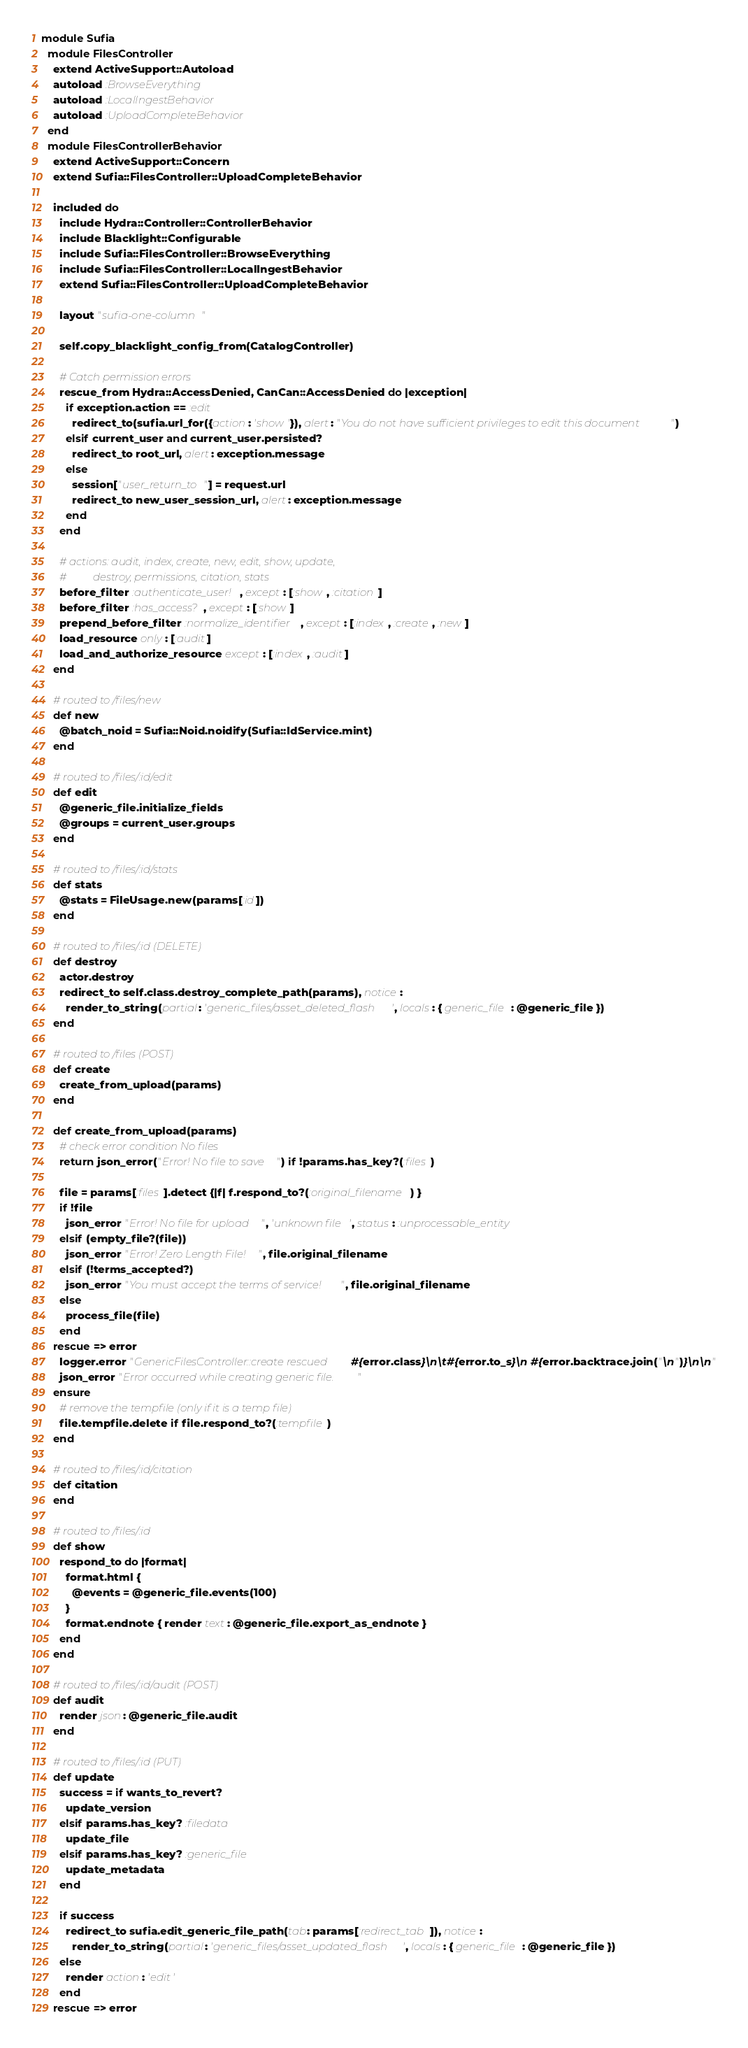Convert code to text. <code><loc_0><loc_0><loc_500><loc_500><_Ruby_>module Sufia
  module FilesController
    extend ActiveSupport::Autoload
    autoload :BrowseEverything
    autoload :LocalIngestBehavior
    autoload :UploadCompleteBehavior
  end
  module FilesControllerBehavior
    extend ActiveSupport::Concern
    extend Sufia::FilesController::UploadCompleteBehavior

    included do
      include Hydra::Controller::ControllerBehavior
      include Blacklight::Configurable
      include Sufia::FilesController::BrowseEverything
      include Sufia::FilesController::LocalIngestBehavior
      extend Sufia::FilesController::UploadCompleteBehavior

      layout "sufia-one-column"

      self.copy_blacklight_config_from(CatalogController)

      # Catch permission errors
      rescue_from Hydra::AccessDenied, CanCan::AccessDenied do |exception|
        if exception.action == :edit
          redirect_to(sufia.url_for({action: 'show'}), alert: "You do not have sufficient privileges to edit this document")
        elsif current_user and current_user.persisted?
          redirect_to root_url, alert: exception.message
        else
          session["user_return_to"] = request.url
          redirect_to new_user_session_url, alert: exception.message
        end
      end

      # actions: audit, index, create, new, edit, show, update,
      #          destroy, permissions, citation, stats
      before_filter :authenticate_user!, except: [:show, :citation]
      before_filter :has_access?, except: [:show]
      prepend_before_filter :normalize_identifier, except: [:index, :create, :new]
      load_resource only: [:audit]
      load_and_authorize_resource except: [:index, :audit]
    end

    # routed to /files/new
    def new
      @batch_noid = Sufia::Noid.noidify(Sufia::IdService.mint)
    end

    # routed to /files/:id/edit
    def edit
      @generic_file.initialize_fields
      @groups = current_user.groups
    end

    # routed to /files/:id/stats
    def stats
      @stats = FileUsage.new(params[:id])
    end

    # routed to /files/:id (DELETE)
    def destroy
      actor.destroy
      redirect_to self.class.destroy_complete_path(params), notice:
        render_to_string(partial: 'generic_files/asset_deleted_flash', locals: { generic_file: @generic_file })
    end

    # routed to /files (POST)
    def create
      create_from_upload(params)
    end

    def create_from_upload(params)
      # check error condition No files
      return json_error("Error! No file to save") if !params.has_key?(:files)

      file = params[:files].detect {|f| f.respond_to?(:original_filename) }
      if !file
        json_error "Error! No file for upload", 'unknown file', status: :unprocessable_entity
      elsif (empty_file?(file))
        json_error "Error! Zero Length File!", file.original_filename
      elsif (!terms_accepted?)
        json_error "You must accept the terms of service!", file.original_filename
      else
        process_file(file)
      end
    rescue => error
      logger.error "GenericFilesController::create rescued #{error.class}\n\t#{error.to_s}\n #{error.backtrace.join("\n")}\n\n"
      json_error "Error occurred while creating generic file."
    ensure
      # remove the tempfile (only if it is a temp file)
      file.tempfile.delete if file.respond_to?(:tempfile)
    end

    # routed to /files/:id/citation
    def citation
    end

    # routed to /files/:id
    def show
      respond_to do |format|
        format.html {
          @events = @generic_file.events(100)
        }
        format.endnote { render text: @generic_file.export_as_endnote }
      end
    end

    # routed to /files/:id/audit (POST)
    def audit
      render json: @generic_file.audit
    end

    # routed to /files/:id (PUT)
    def update
      success = if wants_to_revert?
        update_version
      elsif params.has_key? :filedata
        update_file
      elsif params.has_key? :generic_file
        update_metadata
      end

      if success
        redirect_to sufia.edit_generic_file_path(tab: params[:redirect_tab]), notice:
          render_to_string(partial: 'generic_files/asset_updated_flash', locals: { generic_file: @generic_file })
      else
        render action: 'edit'
      end
    rescue => error</code> 